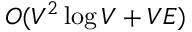<formula> <loc_0><loc_0><loc_500><loc_500>O ( V ^ { 2 } \log { V } + V E )</formula> 